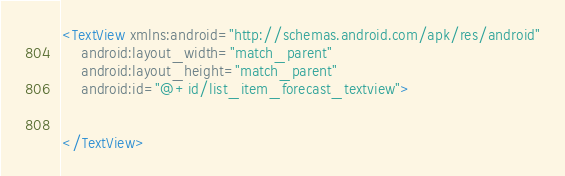<code> <loc_0><loc_0><loc_500><loc_500><_XML_><TextView xmlns:android="http://schemas.android.com/apk/res/android"
    android:layout_width="match_parent"
    android:layout_height="match_parent"
    android:id="@+id/list_item_forecast_textview">


</TextView></code> 